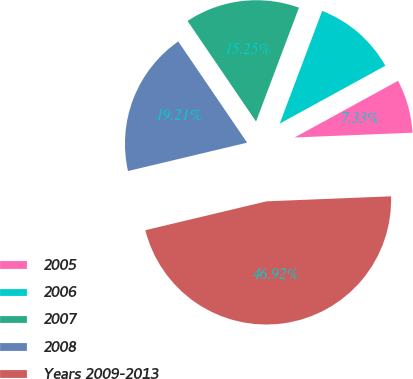Convert chart. <chart><loc_0><loc_0><loc_500><loc_500><pie_chart><fcel>2005<fcel>2006<fcel>2007<fcel>2008<fcel>Years 2009-2013<nl><fcel>7.33%<fcel>11.29%<fcel>15.25%<fcel>19.21%<fcel>46.92%<nl></chart> 